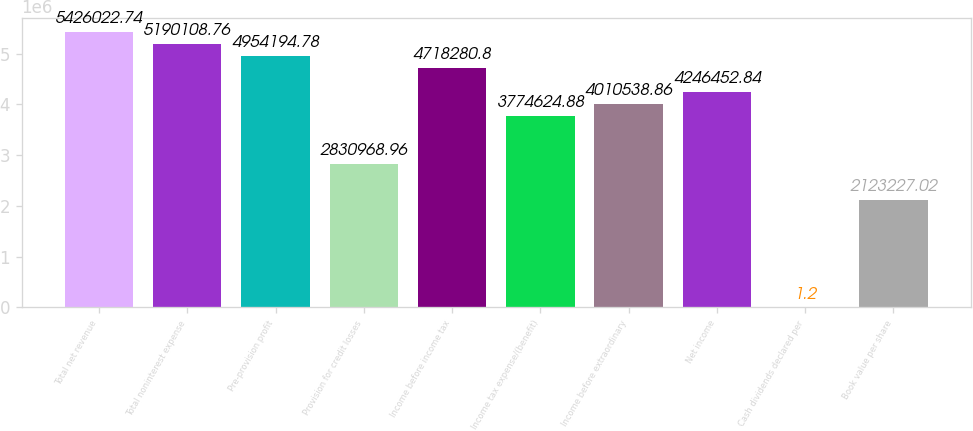Convert chart. <chart><loc_0><loc_0><loc_500><loc_500><bar_chart><fcel>Total net revenue<fcel>Total noninterest expense<fcel>Pre-provision profit<fcel>Provision for credit losses<fcel>Income before income tax<fcel>Income tax expense/(benefit)<fcel>Income before extraordinary<fcel>Net income<fcel>Cash dividends declared per<fcel>Book value per share<nl><fcel>5.42602e+06<fcel>5.19011e+06<fcel>4.95419e+06<fcel>2.83097e+06<fcel>4.71828e+06<fcel>3.77462e+06<fcel>4.01054e+06<fcel>4.24645e+06<fcel>1.2<fcel>2.12323e+06<nl></chart> 